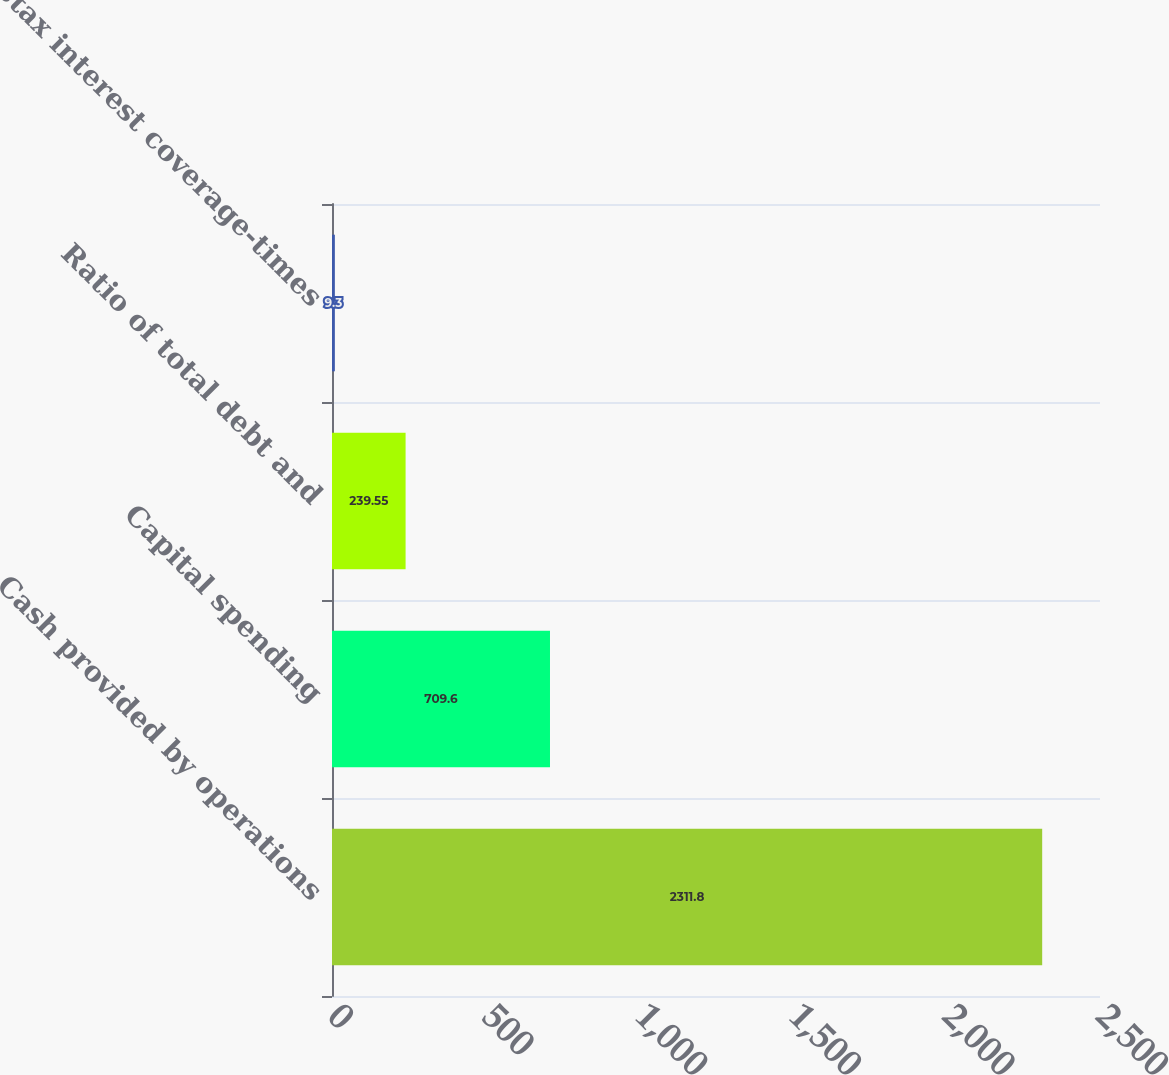Convert chart. <chart><loc_0><loc_0><loc_500><loc_500><bar_chart><fcel>Cash provided by operations<fcel>Capital spending<fcel>Ratio of total debt and<fcel>Pretax interest coverage-times<nl><fcel>2311.8<fcel>709.6<fcel>239.55<fcel>9.3<nl></chart> 